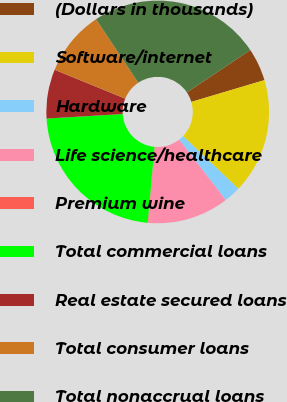Convert chart. <chart><loc_0><loc_0><loc_500><loc_500><pie_chart><fcel>(Dollars in thousands)<fcel>Software/internet<fcel>Hardware<fcel>Life science/healthcare<fcel>Premium wine<fcel>Total commercial loans<fcel>Real estate secured loans<fcel>Total consumer loans<fcel>Total nonaccrual loans<nl><fcel>4.77%<fcel>16.73%<fcel>2.42%<fcel>11.83%<fcel>0.07%<fcel>22.61%<fcel>7.13%<fcel>9.48%<fcel>24.96%<nl></chart> 